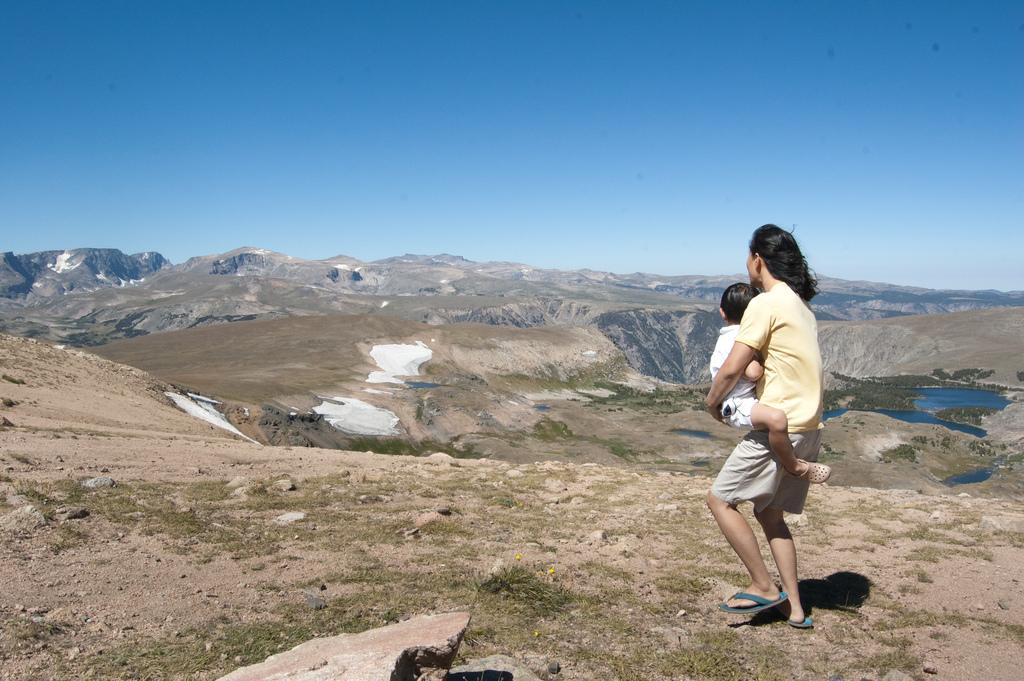What is the person in the image doing? The person is carrying a kid in the image. What type of terrain can be seen in the image? There are rocks, grass, and mountains visible in the image. What natural feature is present in the image? There is water visible in the image. What part of the natural environment is visible in the image? The sky is visible in the image. What type of pipe can be seen in the image? There is no pipe present in the image. How does the queen feel about the situation in the image? There is no queen present in the image, so it is not possible to determine her feelings about the situation. 